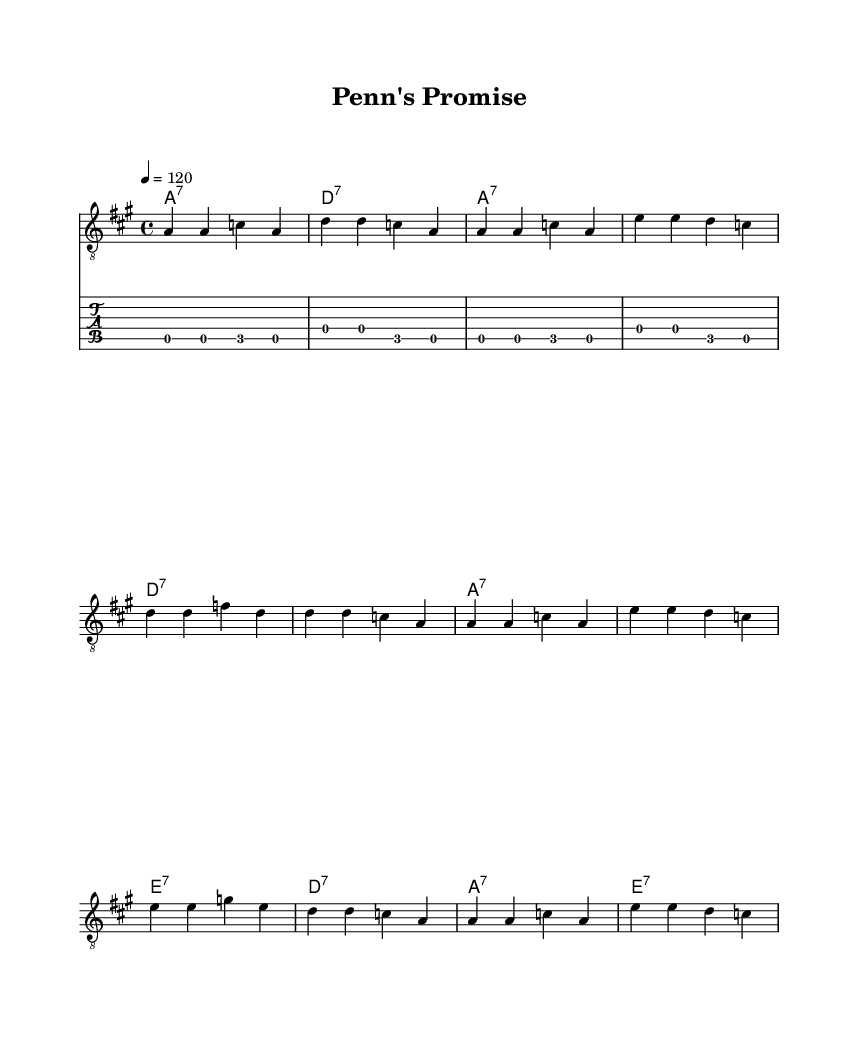What is the key signature of this music? The key signature is A major, which has three sharps: F#, C#, and G#. This can be determined by looking at the key signature section at the beginning of the sheet music, which indicates the key.
Answer: A major What is the time signature of this music? The time signature is 4/4, indicating that there are four beats in each measure and the quarter note gets one beat. This is specified at the beginning of the music right after the key signature.
Answer: 4/4 What is the tempo marking for this piece? The tempo marking is 120 beats per minute. This can typically be found in the tempo section of the score, which defines how fast the piece should be played.
Answer: 120 How many measures are in the melody section? The melody section contains 12 measures. By counting each segment divided by vertical bar lines on the staff, we sum the measures until the end of the melody.
Answer: 12 What chord is played in the first measure? The chord played in the first measure is A7. The chord names are listed on the staff, and the first chord marked in the top line indicates it is an A dominant seventh chord.
Answer: A7 Which historical figure is referenced in the lyrics? The lyrics reference William Penn, who is known for founding Pennsylvania and his vision for a city of brotherly love. This can be confirmed by reading the lyrical text provided under the melody.
Answer: William Penn What kind of musical genre is this piece? This piece is classified as Electric Blues, a genre known for its expressive guitar work and emotional lyrics, recognizable through the specific style reflected in both the music and lyrical themes.
Answer: Electric Blues 